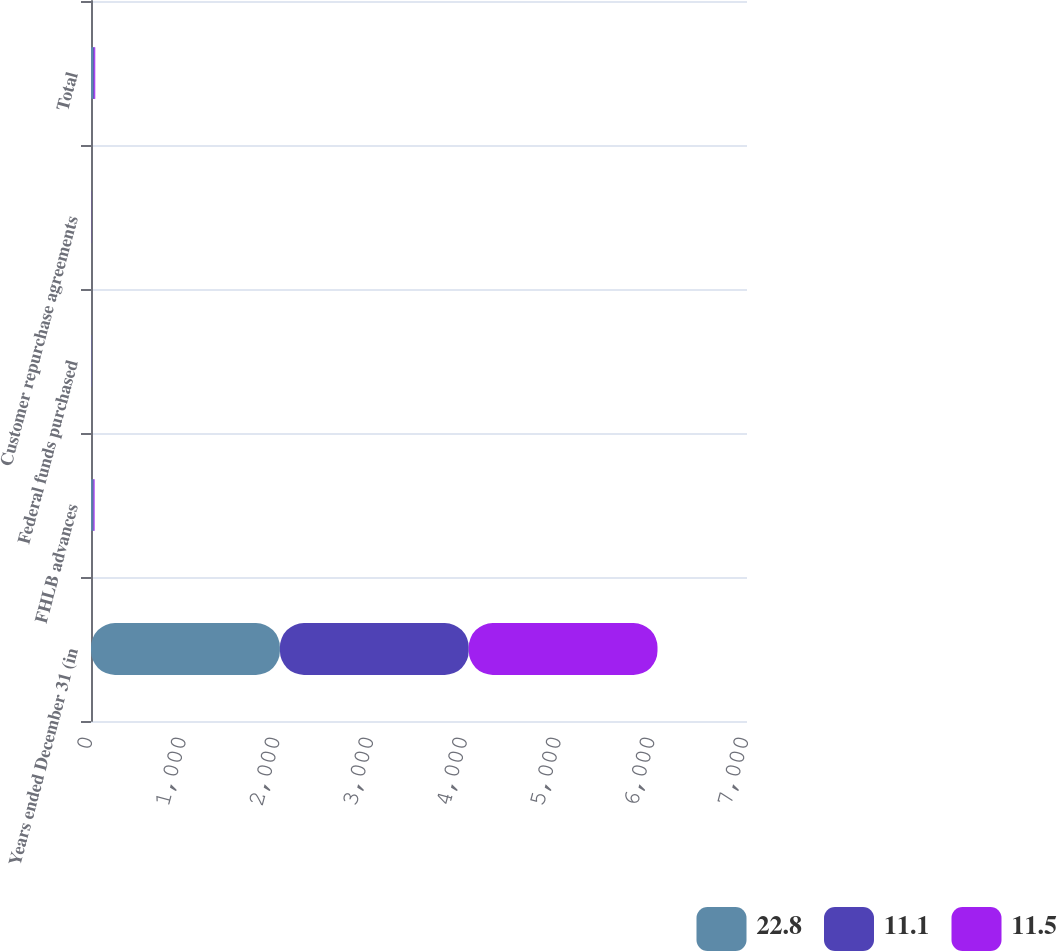Convert chart. <chart><loc_0><loc_0><loc_500><loc_500><stacked_bar_chart><ecel><fcel>Years ended December 31 (in<fcel>FHLB advances<fcel>Federal funds purchased<fcel>Customer repurchase agreements<fcel>Total<nl><fcel>22.8<fcel>2016<fcel>19.3<fcel>2.9<fcel>0.6<fcel>22.8<nl><fcel>11.1<fcel>2015<fcel>9.8<fcel>0.8<fcel>0.9<fcel>11.5<nl><fcel>11.5<fcel>2014<fcel>9.2<fcel>0.8<fcel>1<fcel>11.1<nl></chart> 